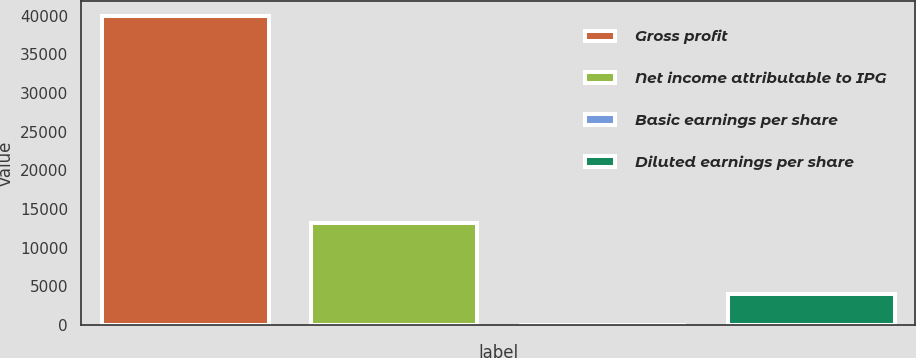Convert chart to OTSL. <chart><loc_0><loc_0><loc_500><loc_500><bar_chart><fcel>Gross profit<fcel>Net income attributable to IPG<fcel>Basic earnings per share<fcel>Diluted earnings per share<nl><fcel>39931<fcel>13226<fcel>0.28<fcel>3993.35<nl></chart> 